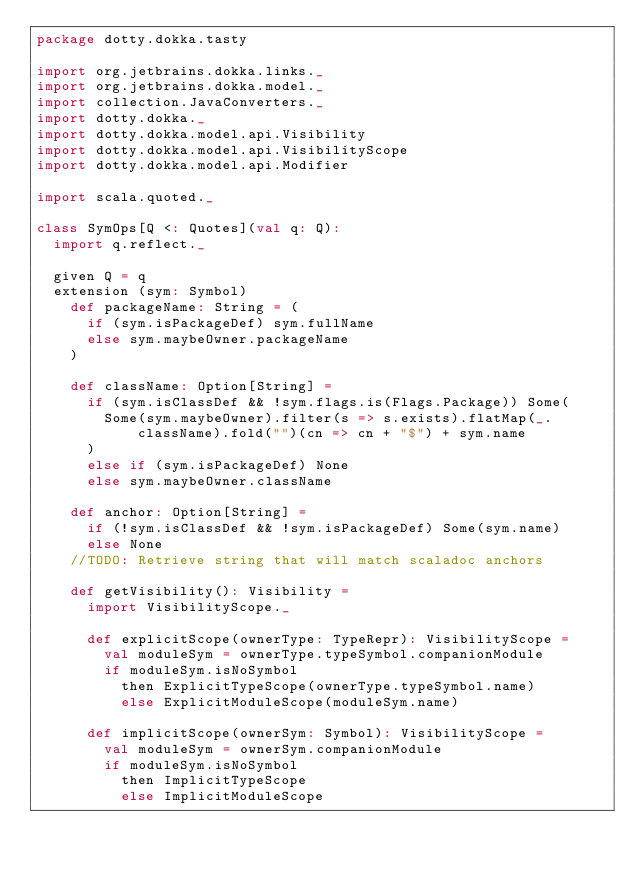Convert code to text. <code><loc_0><loc_0><loc_500><loc_500><_Scala_>package dotty.dokka.tasty

import org.jetbrains.dokka.links._
import org.jetbrains.dokka.model._
import collection.JavaConverters._
import dotty.dokka._
import dotty.dokka.model.api.Visibility
import dotty.dokka.model.api.VisibilityScope
import dotty.dokka.model.api.Modifier

import scala.quoted._

class SymOps[Q <: Quotes](val q: Q):
  import q.reflect._

  given Q = q
  extension (sym: Symbol)
    def packageName: String = (
      if (sym.isPackageDef) sym.fullName
      else sym.maybeOwner.packageName
    )

    def className: Option[String] =
      if (sym.isClassDef && !sym.flags.is(Flags.Package)) Some(
        Some(sym.maybeOwner).filter(s => s.exists).flatMap(_.className).fold("")(cn => cn + "$") + sym.name
      )
      else if (sym.isPackageDef) None
      else sym.maybeOwner.className

    def anchor: Option[String] =
      if (!sym.isClassDef && !sym.isPackageDef) Some(sym.name)
      else None
    //TODO: Retrieve string that will match scaladoc anchors

    def getVisibility(): Visibility =
      import VisibilityScope._

      def explicitScope(ownerType: TypeRepr): VisibilityScope =
        val moduleSym = ownerType.typeSymbol.companionModule
        if moduleSym.isNoSymbol
          then ExplicitTypeScope(ownerType.typeSymbol.name)
          else ExplicitModuleScope(moduleSym.name)

      def implicitScope(ownerSym: Symbol): VisibilityScope =
        val moduleSym = ownerSym.companionModule
        if moduleSym.isNoSymbol
          then ImplicitTypeScope
          else ImplicitModuleScope
</code> 